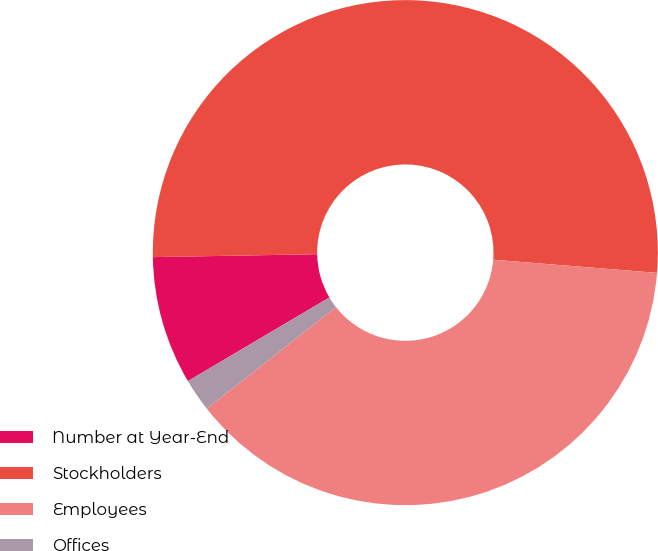Convert chart to OTSL. <chart><loc_0><loc_0><loc_500><loc_500><pie_chart><fcel>Number at Year-End<fcel>Stockholders<fcel>Employees<fcel>Offices<nl><fcel>8.21%<fcel>51.56%<fcel>38.12%<fcel>2.11%<nl></chart> 